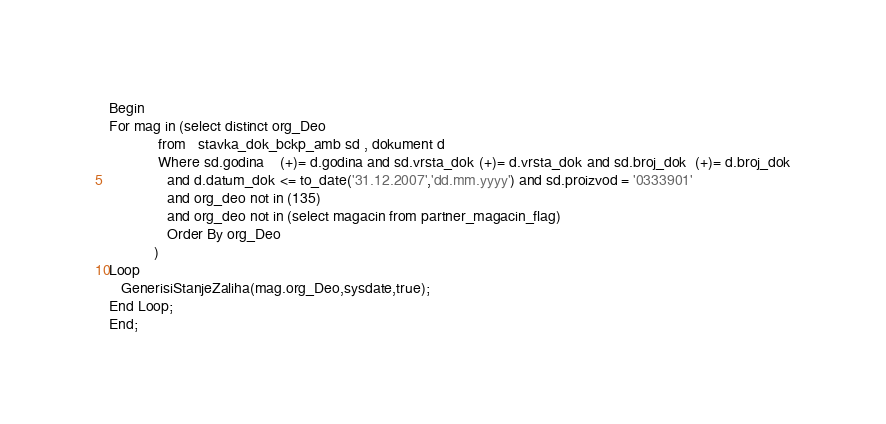Convert code to text. <code><loc_0><loc_0><loc_500><loc_500><_SQL_>Begin
For mag in (select distinct org_Deo
            from   stavka_dok_bckp_amb sd , dokument d
            Where sd.godina    (+)= d.godina and sd.vrsta_dok (+)= d.vrsta_dok and sd.broj_dok  (+)= d.broj_dok
              and d.datum_dok <= to_date('31.12.2007','dd.mm.yyyy') and sd.proizvod = '0333901'
              and org_deo not in (135)
              and org_deo not in (select magacin from partner_magacin_flag)
              Order By org_Deo
           )
Loop
   GenerisiStanjeZaliha(mag.org_Deo,sysdate,true);
End Loop;
End;
</code> 